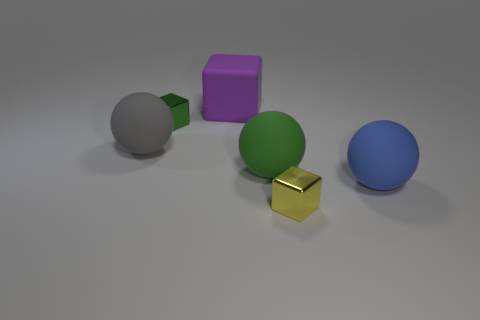What is the material of the large green object that is the same shape as the big gray thing?
Ensure brevity in your answer.  Rubber. What number of other things are there of the same shape as the green matte object?
Keep it short and to the point. 2. What shape is the big green object that is the same material as the blue sphere?
Make the answer very short. Sphere. There is a block that is both behind the tiny yellow metallic block and in front of the purple matte thing; what color is it?
Give a very brief answer. Green. Do the thing to the left of the green metal cube and the large purple cube have the same material?
Offer a terse response. Yes. Are there fewer rubber objects that are in front of the large purple rubber thing than tiny yellow blocks?
Give a very brief answer. No. Are there any big green things made of the same material as the large blue sphere?
Make the answer very short. Yes. There is a yellow thing; is its size the same as the sphere that is left of the large purple matte cube?
Your response must be concise. No. Is there a big ball of the same color as the big matte cube?
Provide a short and direct response. No. Does the green block have the same material as the blue ball?
Keep it short and to the point. No. 